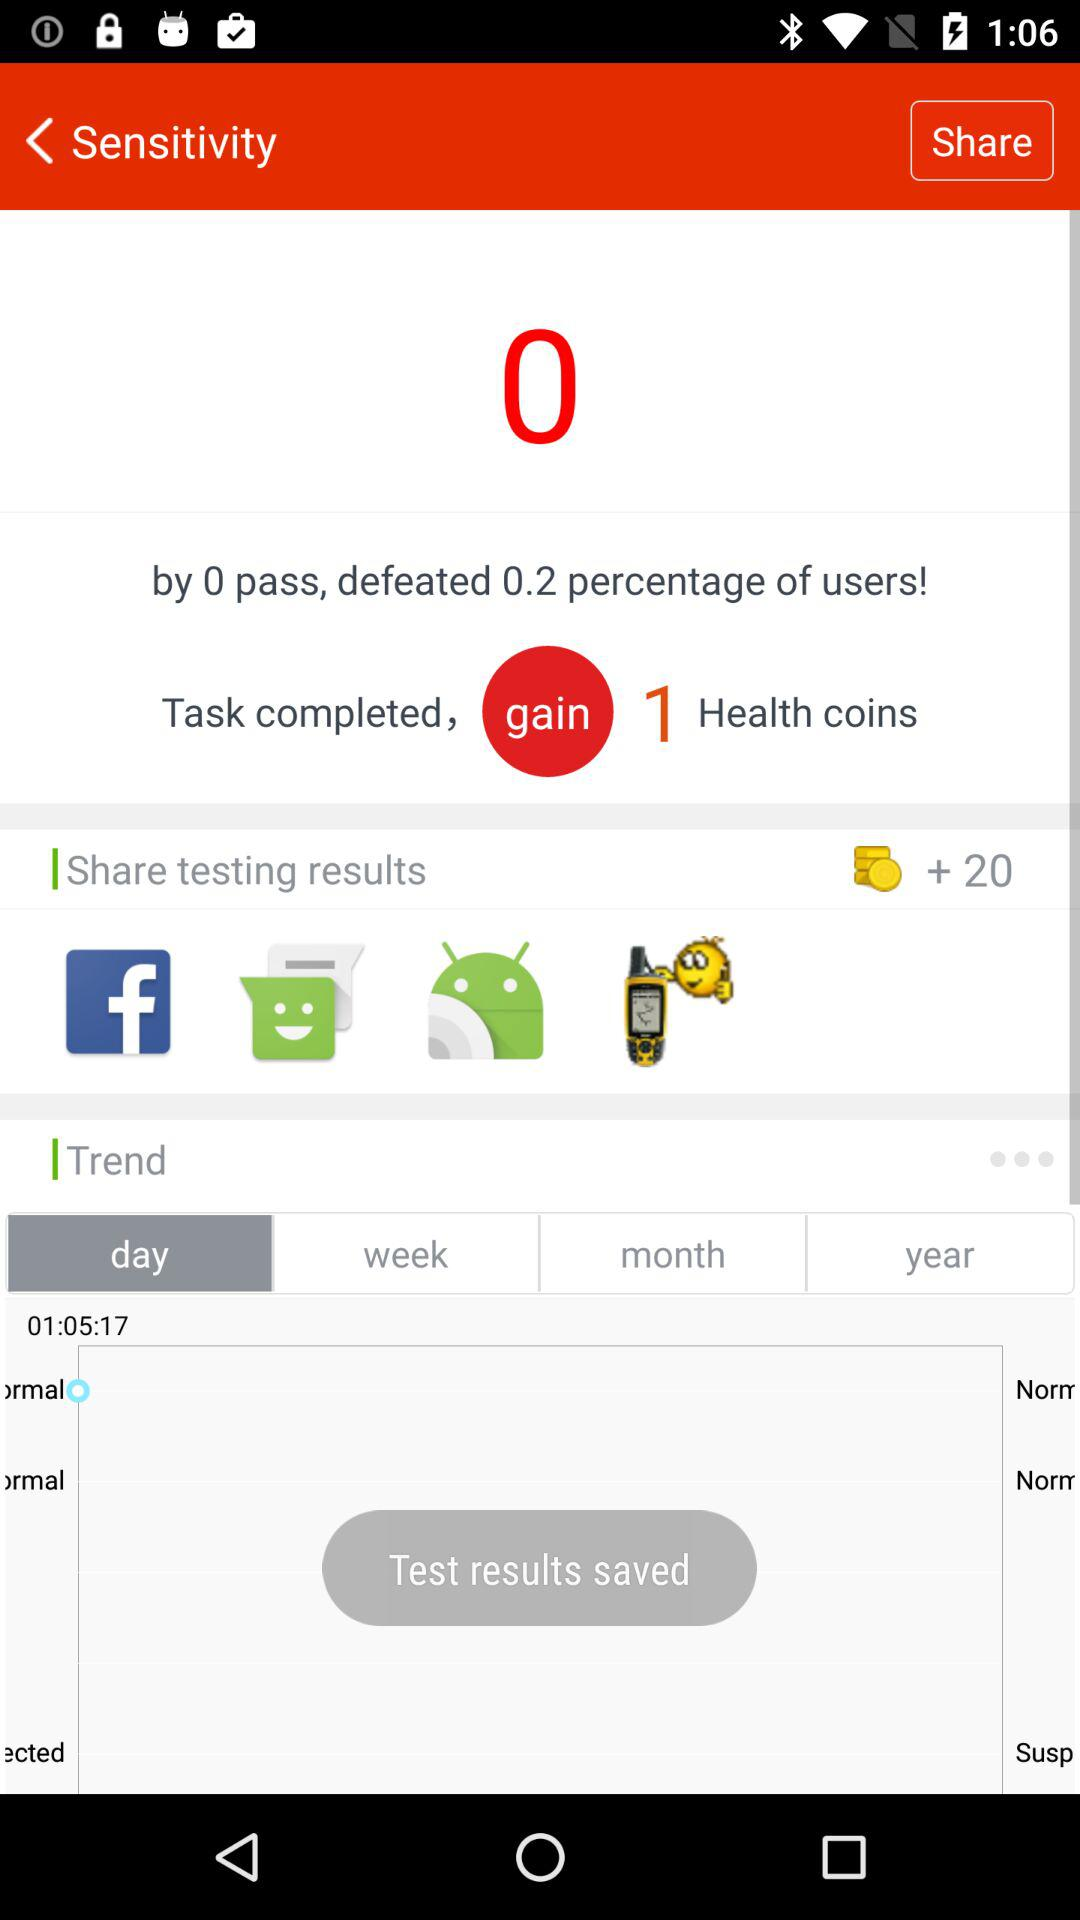What percentage of users are defeated by 0 passes? The percentage of users that are defeated by 0 passes is 0.2. 